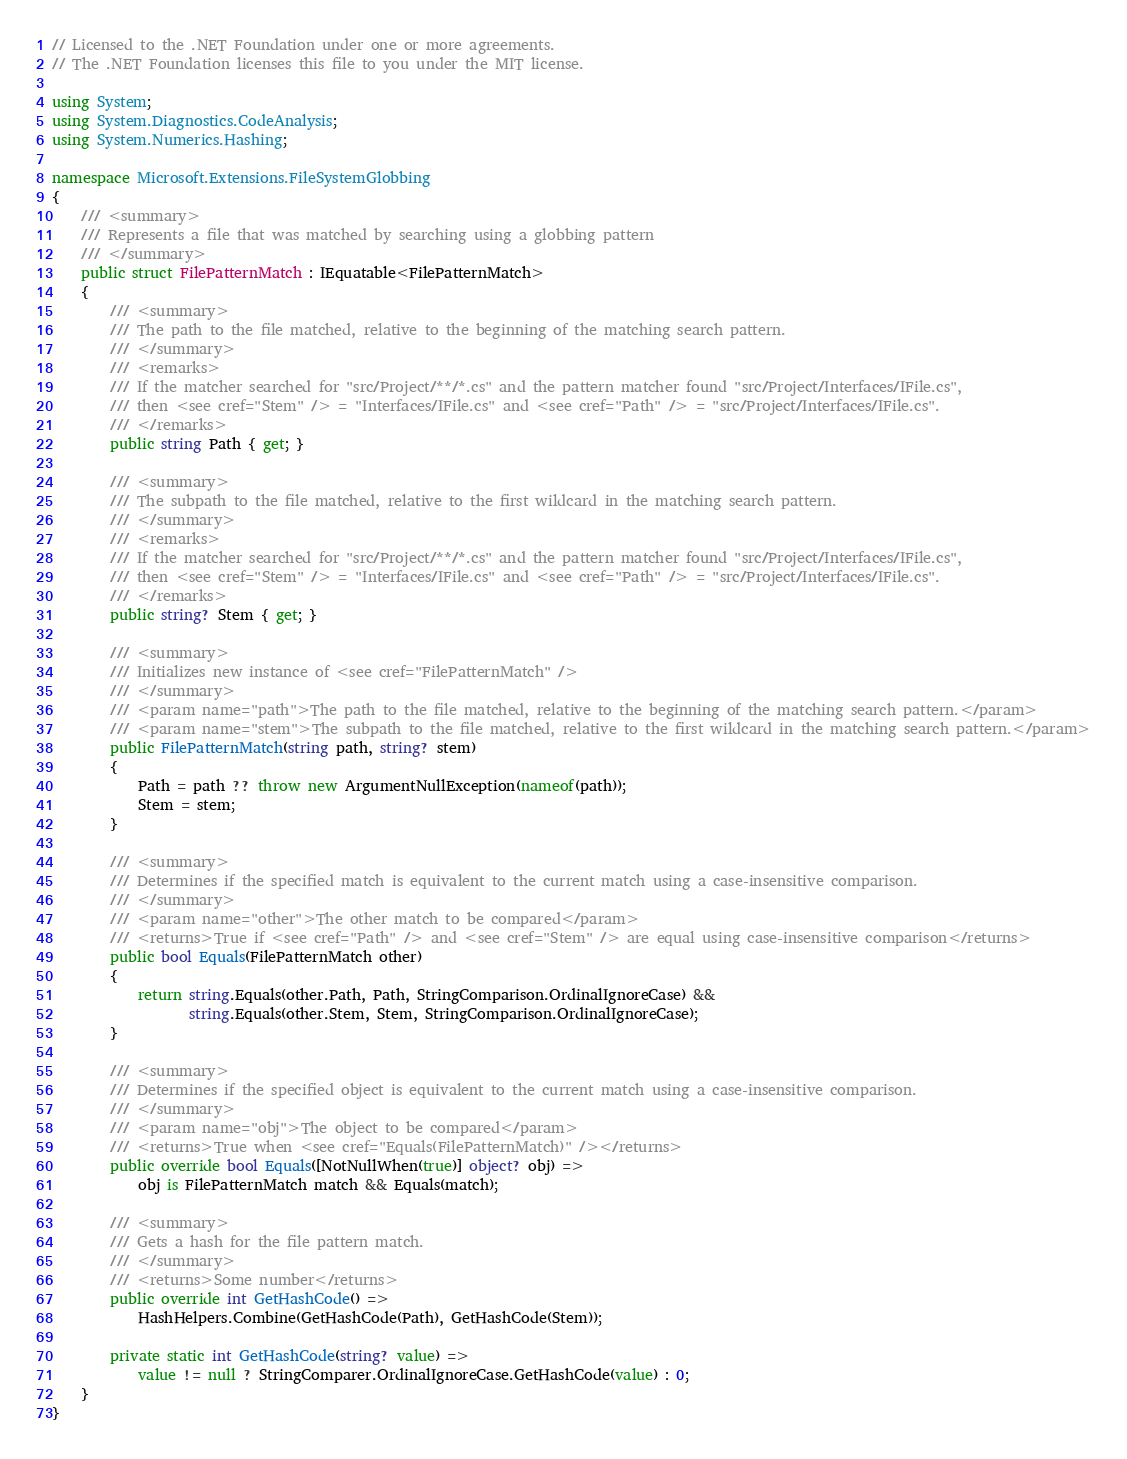Convert code to text. <code><loc_0><loc_0><loc_500><loc_500><_C#_>// Licensed to the .NET Foundation under one or more agreements.
// The .NET Foundation licenses this file to you under the MIT license.

using System;
using System.Diagnostics.CodeAnalysis;
using System.Numerics.Hashing;

namespace Microsoft.Extensions.FileSystemGlobbing
{
    /// <summary>
    /// Represents a file that was matched by searching using a globbing pattern
    /// </summary>
    public struct FilePatternMatch : IEquatable<FilePatternMatch>
    {
        /// <summary>
        /// The path to the file matched, relative to the beginning of the matching search pattern.
        /// </summary>
        /// <remarks>
        /// If the matcher searched for "src/Project/**/*.cs" and the pattern matcher found "src/Project/Interfaces/IFile.cs",
        /// then <see cref="Stem" /> = "Interfaces/IFile.cs" and <see cref="Path" /> = "src/Project/Interfaces/IFile.cs".
        /// </remarks>
        public string Path { get; }

        /// <summary>
        /// The subpath to the file matched, relative to the first wildcard in the matching search pattern.
        /// </summary>
        /// <remarks>
        /// If the matcher searched for "src/Project/**/*.cs" and the pattern matcher found "src/Project/Interfaces/IFile.cs",
        /// then <see cref="Stem" /> = "Interfaces/IFile.cs" and <see cref="Path" /> = "src/Project/Interfaces/IFile.cs".
        /// </remarks>
        public string? Stem { get; }

        /// <summary>
        /// Initializes new instance of <see cref="FilePatternMatch" />
        /// </summary>
        /// <param name="path">The path to the file matched, relative to the beginning of the matching search pattern.</param>
        /// <param name="stem">The subpath to the file matched, relative to the first wildcard in the matching search pattern.</param>
        public FilePatternMatch(string path, string? stem)
        {
            Path = path ?? throw new ArgumentNullException(nameof(path));
            Stem = stem;
        }

        /// <summary>
        /// Determines if the specified match is equivalent to the current match using a case-insensitive comparison.
        /// </summary>
        /// <param name="other">The other match to be compared</param>
        /// <returns>True if <see cref="Path" /> and <see cref="Stem" /> are equal using case-insensitive comparison</returns>
        public bool Equals(FilePatternMatch other)
        {
            return string.Equals(other.Path, Path, StringComparison.OrdinalIgnoreCase) &&
                   string.Equals(other.Stem, Stem, StringComparison.OrdinalIgnoreCase);
        }

        /// <summary>
        /// Determines if the specified object is equivalent to the current match using a case-insensitive comparison.
        /// </summary>
        /// <param name="obj">The object to be compared</param>
        /// <returns>True when <see cref="Equals(FilePatternMatch)" /></returns>
        public override bool Equals([NotNullWhen(true)] object? obj) =>
            obj is FilePatternMatch match && Equals(match);

        /// <summary>
        /// Gets a hash for the file pattern match.
        /// </summary>
        /// <returns>Some number</returns>
        public override int GetHashCode() =>
            HashHelpers.Combine(GetHashCode(Path), GetHashCode(Stem));

        private static int GetHashCode(string? value) =>
            value != null ? StringComparer.OrdinalIgnoreCase.GetHashCode(value) : 0;
    }
}
</code> 